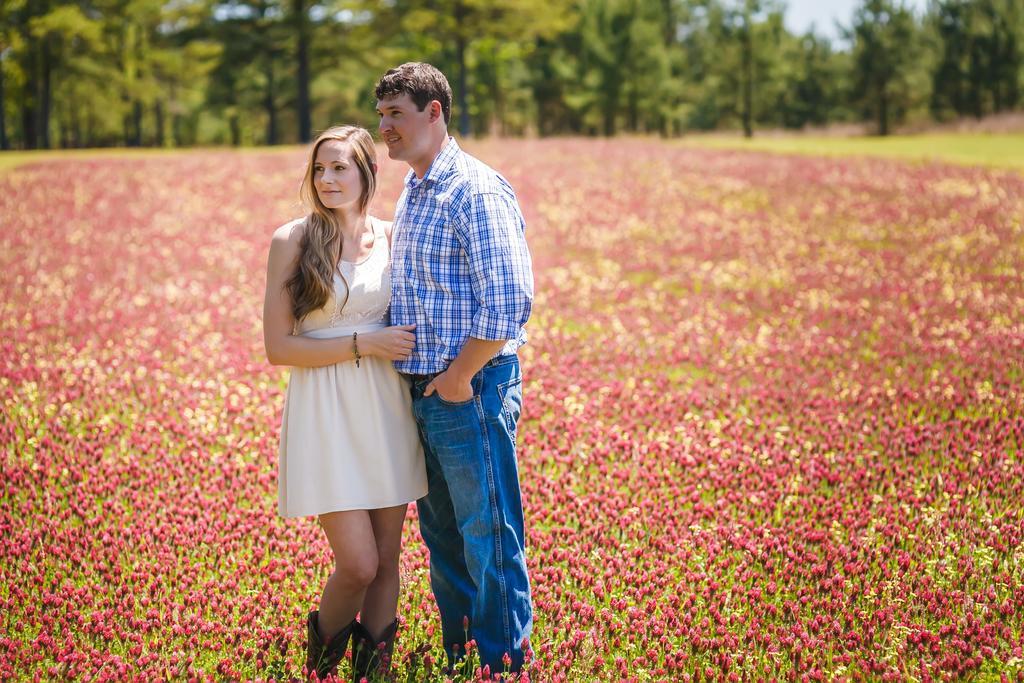Please provide a concise description of this image. In this image in the foreground there is one man and one woman who are standing, and in the background there are some flowers and plants and some trees. 